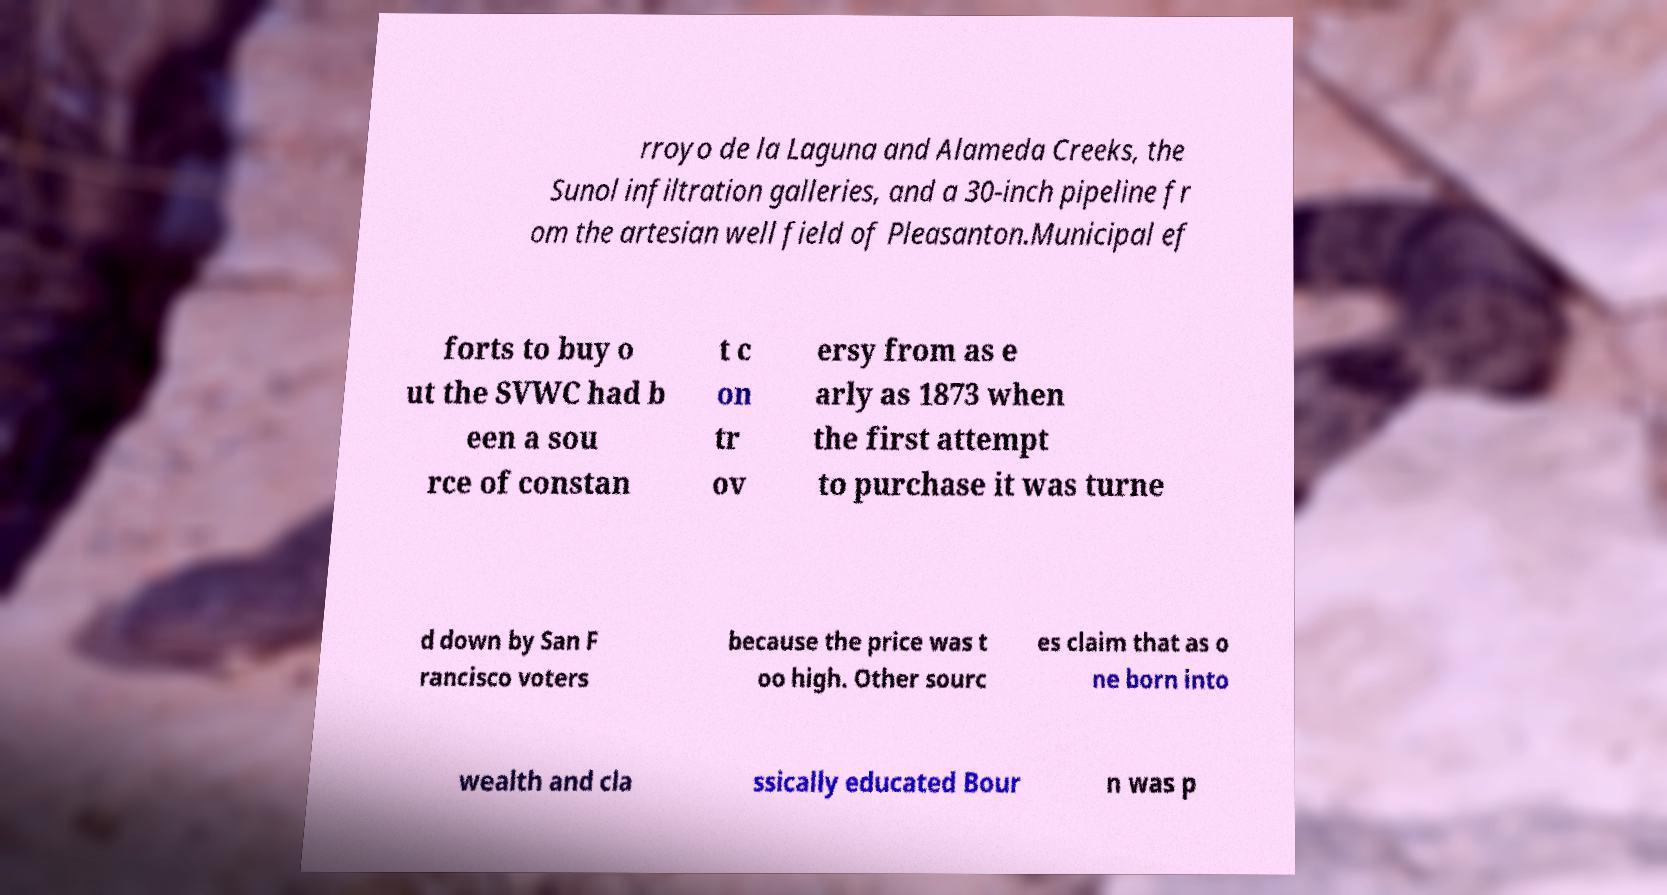I need the written content from this picture converted into text. Can you do that? rroyo de la Laguna and Alameda Creeks, the Sunol infiltration galleries, and a 30-inch pipeline fr om the artesian well field of Pleasanton.Municipal ef forts to buy o ut the SVWC had b een a sou rce of constan t c on tr ov ersy from as e arly as 1873 when the first attempt to purchase it was turne d down by San F rancisco voters because the price was t oo high. Other sourc es claim that as o ne born into wealth and cla ssically educated Bour n was p 